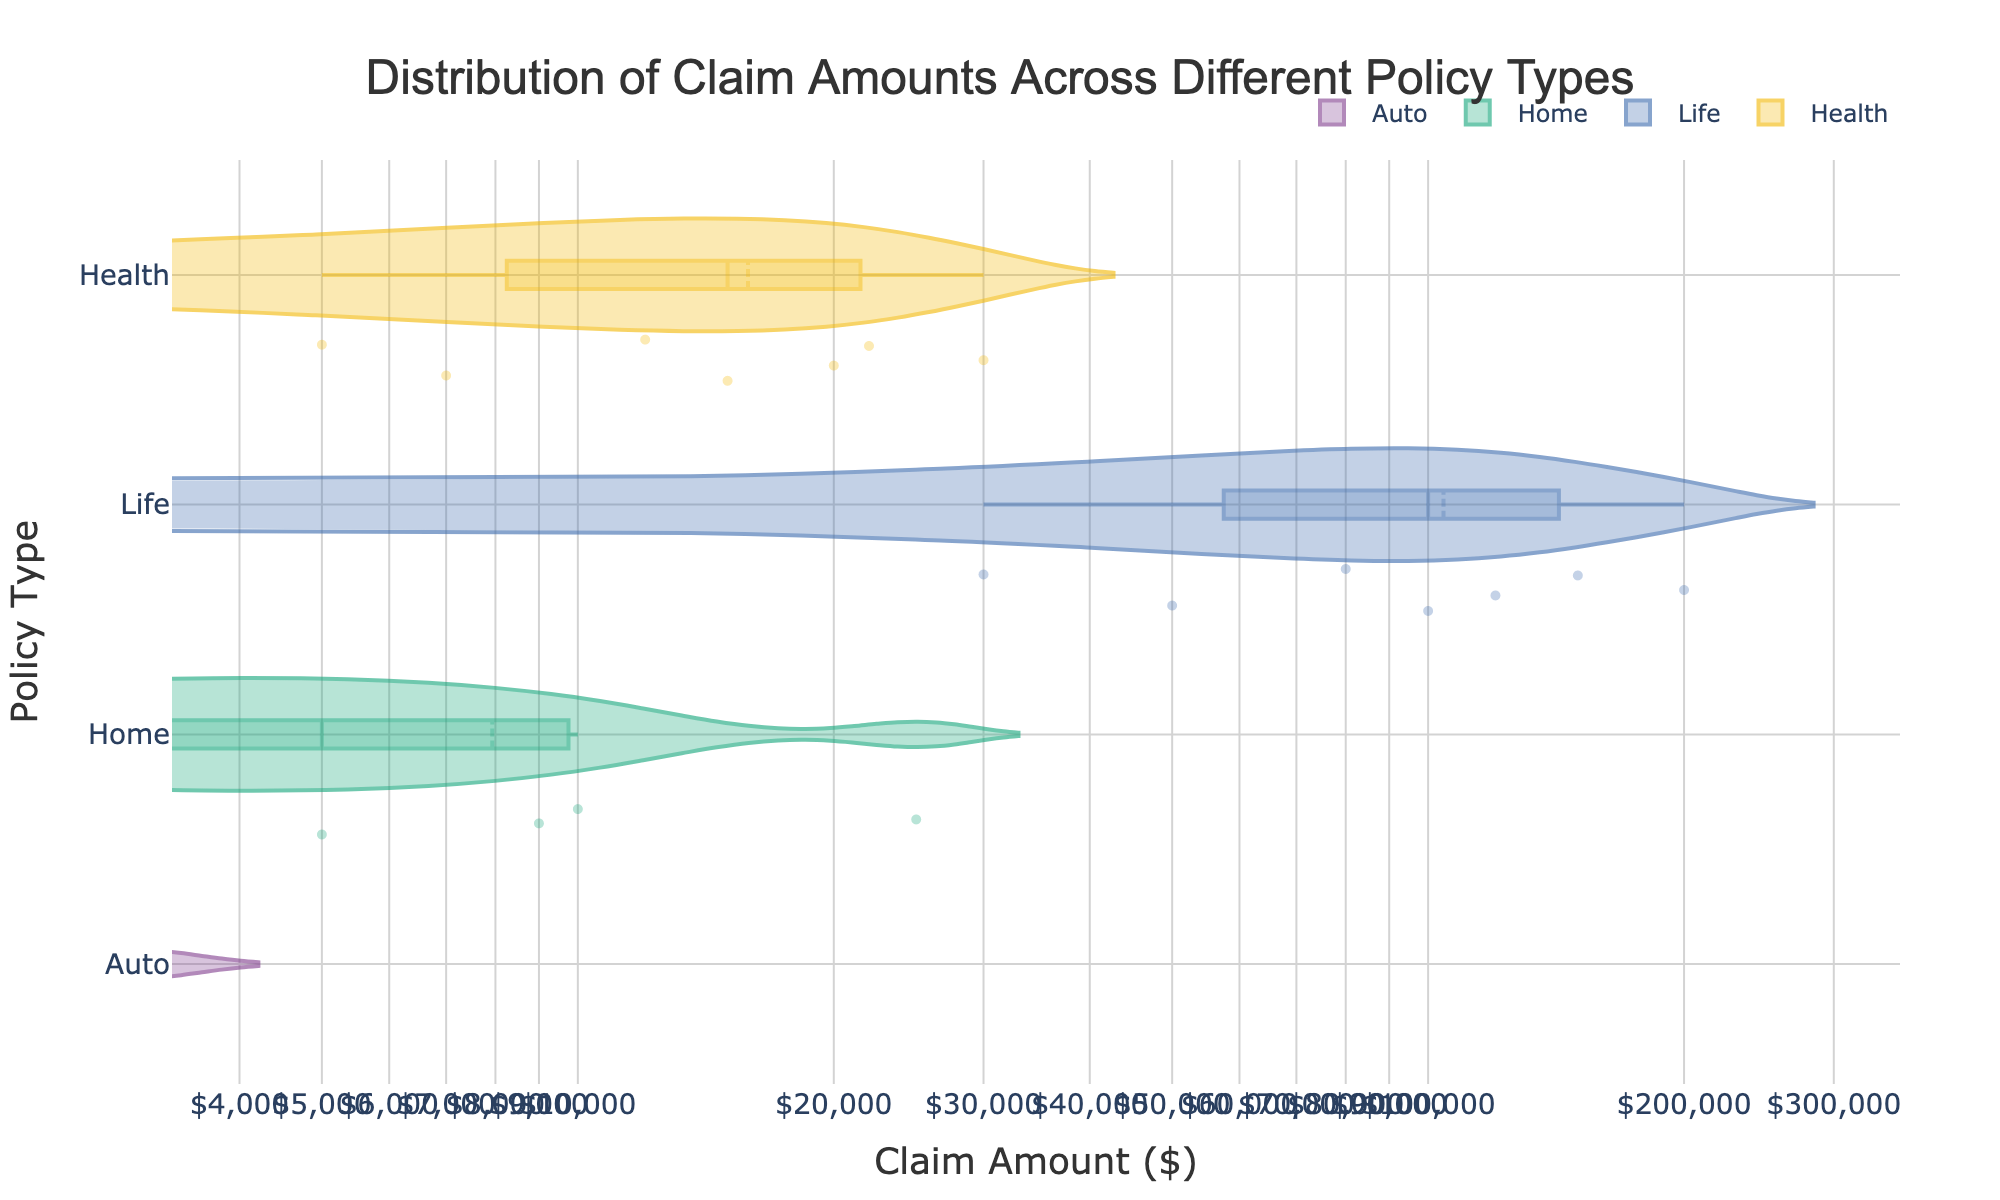What is the title of the plot? The title of the plot is usually displayed at the top of the chart, highlighting the main subject. Here, the title is "Distribution of Claim Amounts Across Different Policy Types" as stated in the code.
Answer: Distribution of Claim Amounts Across Different Policy Types What are the labels for the x-axis and y-axis? The x-axis label typically describes what the horizontal axis represents, and the y-axis label describes the vertical axis. According to the code, the x-axis is labeled "Claim Amount ($)" and the y-axis is labeled "Policy Type".
Answer: x-axis: Claim Amount ($); y-axis: Policy Type Which policy type has the highest median claim amount? To find the highest median claim amount, look for the median line inside each violin plot. According to the data and the likely arrangement, "Life" has the highest median claim amount.
Answer: Life Which policy type has the widest range of claim amounts? The range of claim amounts can be observed through the spread of the violin plot. The policy type "Life" has a very wide distribution from lowest to highest claim amounts, indicating the widest range.
Answer: Life How do claim amounts in "Home" insurance compare to "Auto" insurance? To compare these, observe the spread and central tendency of the violin plots for "Home" and "Auto". "Home" insurance claim amounts are generally higher and more spread out compared to "Auto".
Answer: "Home" claim amounts are higher and more spread out What is the least common claim amount for "Health" policy type? Since the violin plot points to the density of data, less dense areas correspond to less common values. Based on the more spread out and less frequent points, the highest amount (30,000) appears less common.
Answer: 30,000 Which policy type shows the most variation in claim amounts? Variation is indicated by the spread and fullness of the violin plot. "Life" shows the most variation in claim amounts due to its wide and dense distribution.
Answer: Life Compare the maximum claim amount for "Auto" and "Health". The maximum amounts can be seen from the farthest right points in each violin plot. The "Auto" maximum is 3000, and for "Health" it is 30,000.
Answer: Health has a higher maximum What is unique about the claim distribution for "Life" insurance? "Life" insurance displays a unique characteristic with extremely high claim amounts and a widely spread distribution, indicating highly variable claims from 30,000 to 200,000 and beyond.
Answer: Extremely high and variable claim amounts 